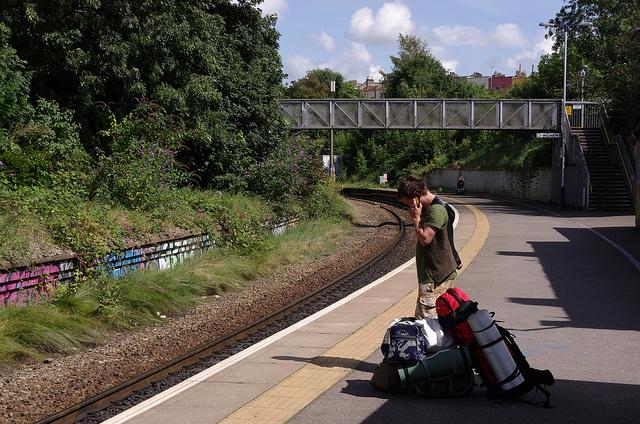What's the first color we see in the wall?
Give a very brief answer. Pink. Are there stairs in this photo?
Be succinct. Yes. Does this man need a ride?
Short answer required. Yes. 